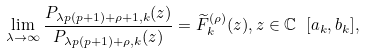<formula> <loc_0><loc_0><loc_500><loc_500>\lim _ { \lambda \rightarrow \infty } \frac { P _ { \lambda p ( p + 1 ) + \rho + 1 , k } ( z ) } { P _ { \lambda p ( p + 1 ) + \rho , k } ( z ) } = \widetilde { F } _ { k } ^ { ( \rho ) } ( z ) , z \in \mathbb { C } \ [ a _ { k } , b _ { k } ] ,</formula> 